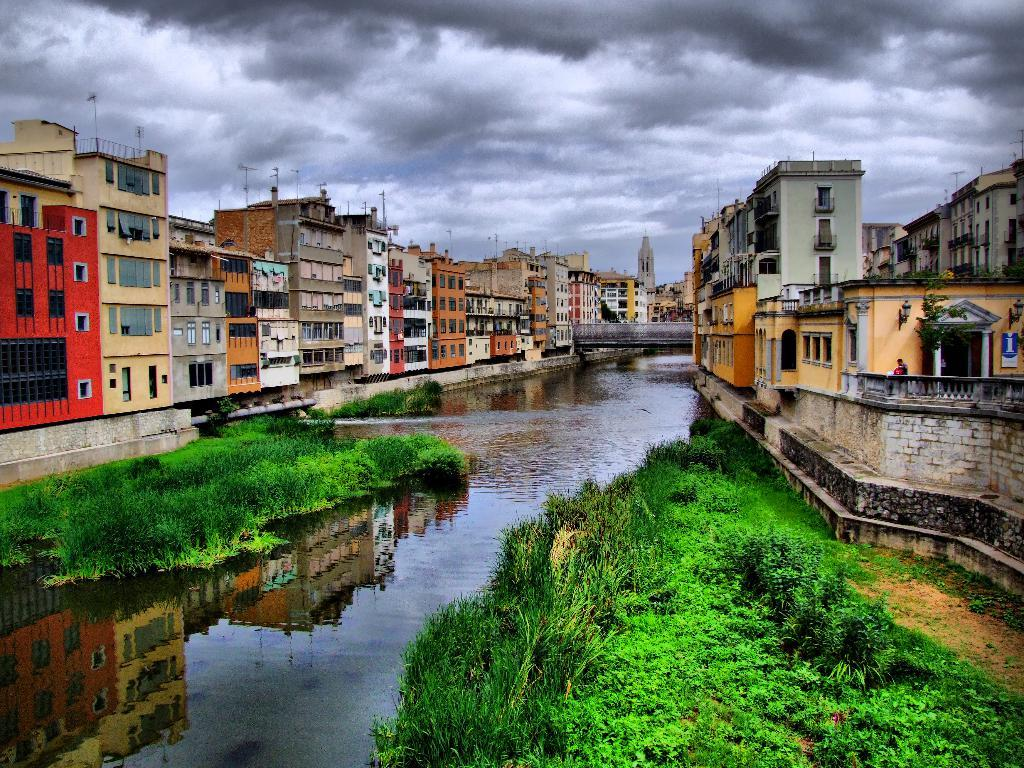What type of structures can be seen in the image? There are buildings in the image. What feature is common to many of the buildings? There are windows visible in the image. What architectural element connects two areas in the image? There is a bridge in the image. What can be seen above the buildings and bridge in the image? The sky is visible in the image. What type of vegetation is present in the image? There are plants in the image. What type of ground cover is visible in the image? There is grass visible in the image. What type of music can be heard playing in the background of the image? There is no music present in the image, as it is a visual representation and does not include sound. Is there any evidence of a battle taking place in the image? There is no indication of a battle or any conflict in the image. 